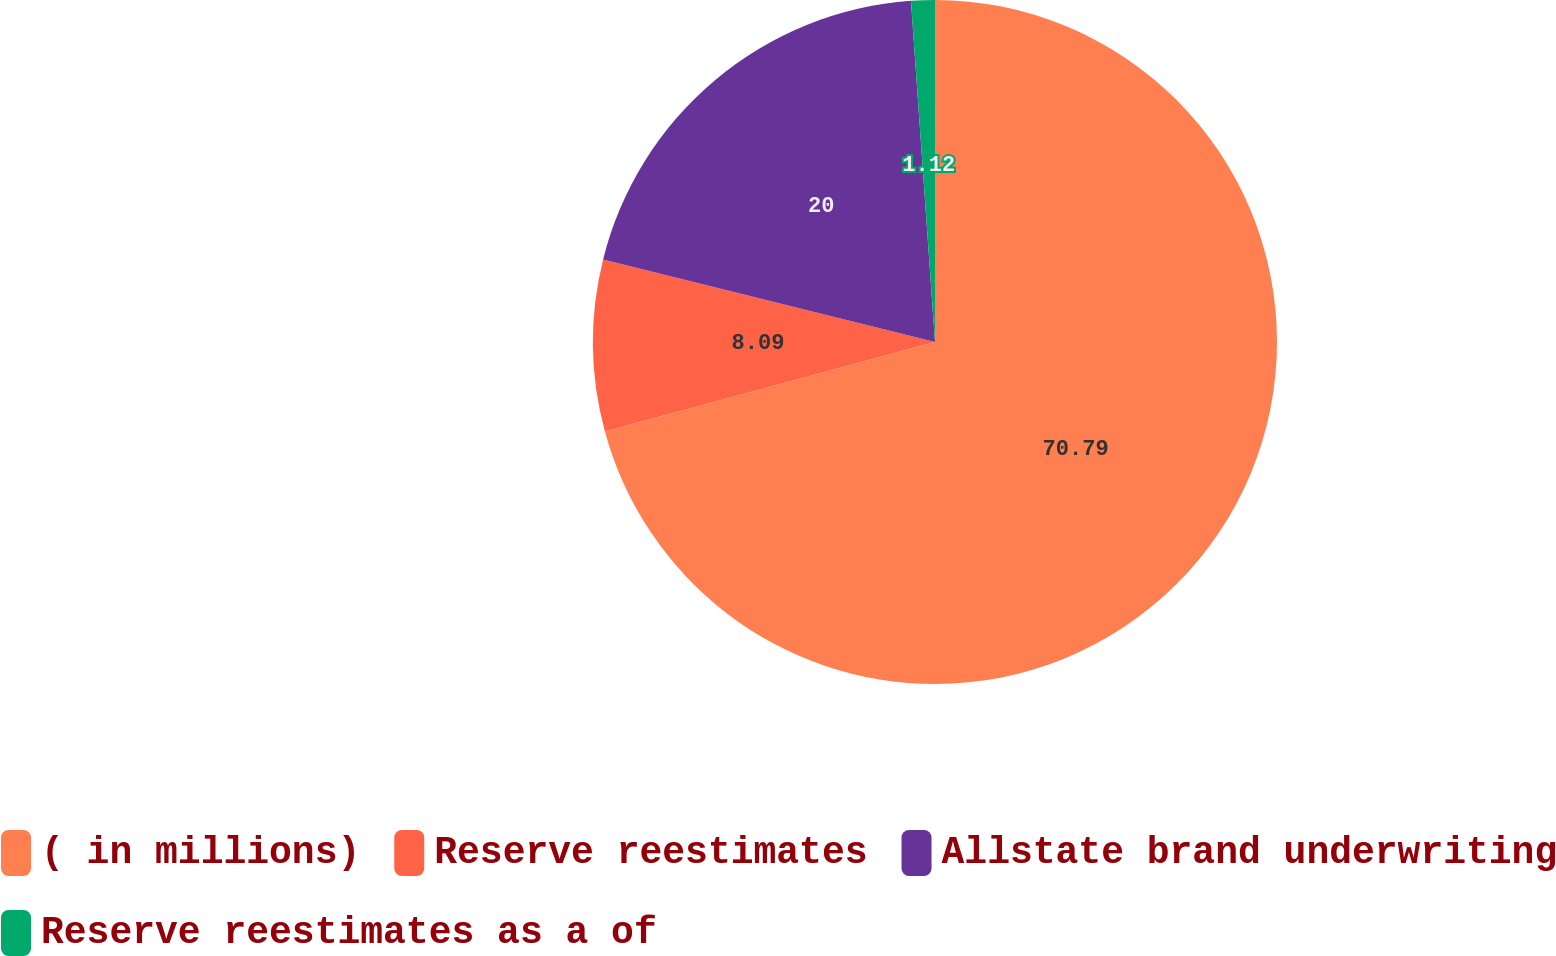<chart> <loc_0><loc_0><loc_500><loc_500><pie_chart><fcel>( in millions)<fcel>Reserve reestimates<fcel>Allstate brand underwriting<fcel>Reserve reestimates as a of<nl><fcel>70.78%<fcel>8.09%<fcel>20.0%<fcel>1.12%<nl></chart> 